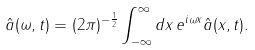<formula> <loc_0><loc_0><loc_500><loc_500>\hat { a } ( \omega , t ) = ( 2 \pi ) ^ { - \frac { 1 } { 2 } } \int _ { - \infty } ^ { \infty } d x \, e ^ { i \omega x } \hat { a } ( x , t ) .</formula> 